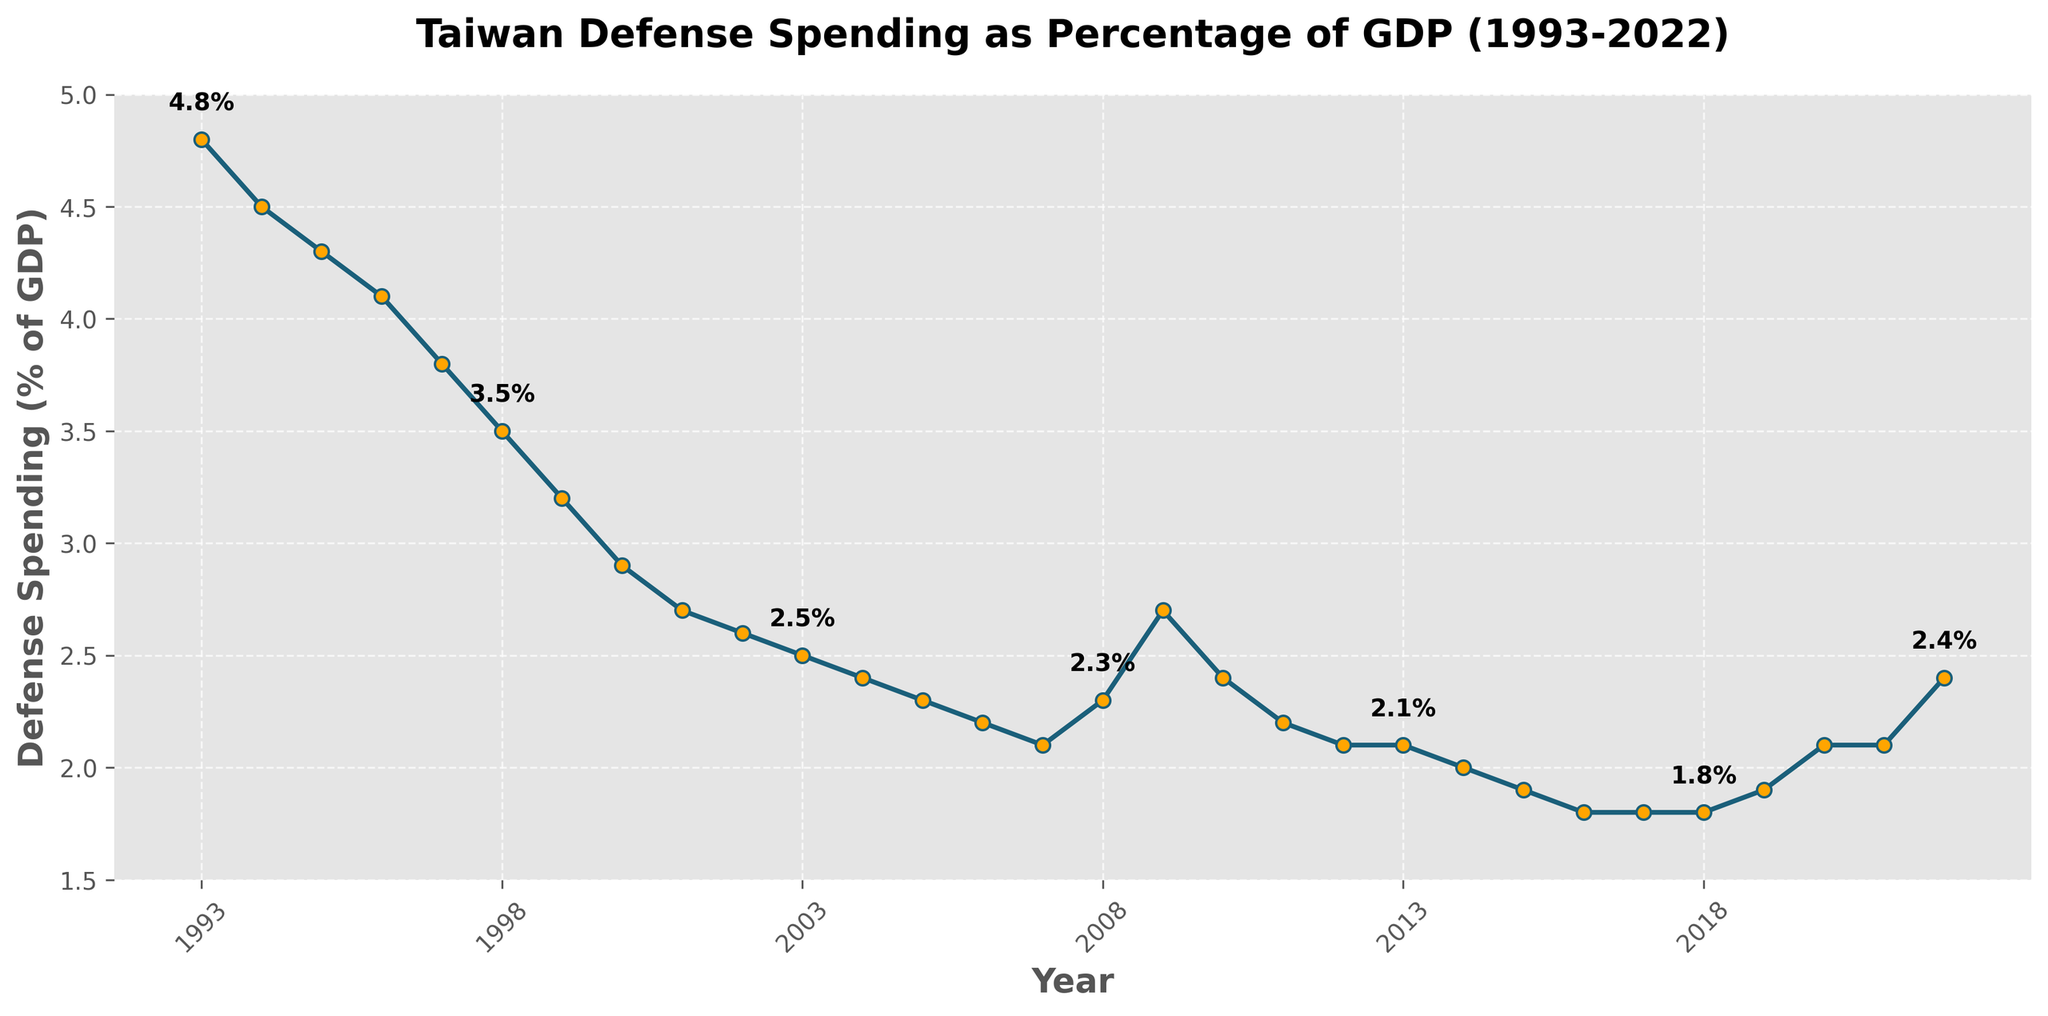Which year had the highest defense spending as a percentage of GDP? By visually inspecting the y-axis and the line plot, the highest point appears around the year 1993.
Answer: 1993 What is the average defense spending percentage of GDP from 2000 to 2010? From the figure, the values for the years 2000 to 2010 are (2.9, 2.7, 2.6, 2.5, 2.4, 2.3, 2.2, 2.3, 2.7, 2.4, 2.2). The sum is 27.2, and dividing by 11 gives the average.
Answer: 2.47% How does the defense spending percentage in 2022 compare to that in 2015? The plot shows the value for 2022 is 2.4, while for 2015 it is 1.9. Thus, the value in 2022 is higher.
Answer: Higher in 2022 What is the overall trend in the defense spending percentage from 1993 to 2022? By observing the line plot from left to right, it starts high and generally decreases with some fluctuations, indicating a downward trend over the period.
Answer: Downward trend Which years show an upward trend in defense spending percentage? Reviewing the plot, the years with upward trends are 2008-2009, 2009-2010, and 2019-2022 as the values visibly increase during these periods.
Answer: 2008-2009, 2009-2010, 2019-2022 What was the percentage change in defense spending between 1993 and 2000? The values are 4.8% (1993) and 2.9% (2000). The percentage change is calculated as ((2.9 - 4.8) / 4.8) * 100.
Answer: Approximately -39.58% Which year had the lowest defense spending as a percentage of GDP? By visually inspecting the y-axis and the line plot, the lowest point appears around 2016.
Answer: 2016 What is the difference in defense spending percentage between 1995 and 2010? The values from the plot are 4.3% (1995) and 2.4% (2010). The difference is 4.3 - 2.4.
Answer: 1.9% How often did the defense spending percentage exceed 4.0% of GDP? By examining the plot, it is clear that the percentage spending exceeded 4.0% during the years 1993-1996.
Answer: 4 years What was the average defense spending percentage of GDP in the first decade (1993-2002)? Summing the values from 1993 through 2002 and then dividing by 10: (4.8 + 4.5 + 4.3 + 4.1 + 3.8 + 3.5 + 3.2 + 2.9 + 2.7 + 2.6) which totals 36.4, and dividing by 10 gives 3.64%.
Answer: 3.64% 